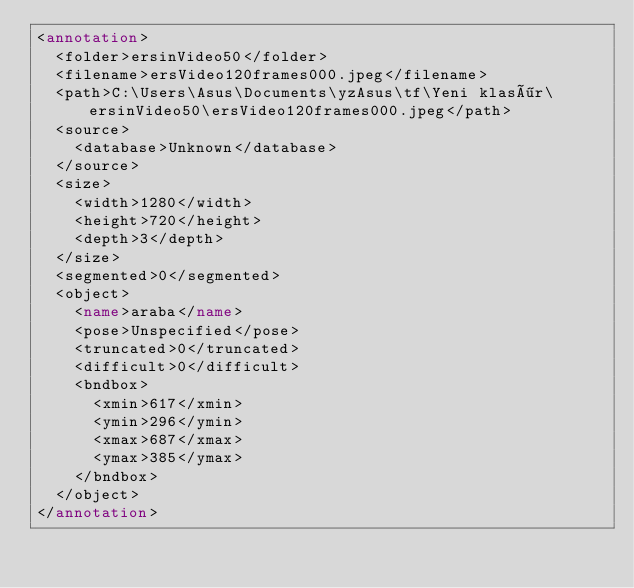Convert code to text. <code><loc_0><loc_0><loc_500><loc_500><_XML_><annotation>
	<folder>ersinVideo50</folder>
	<filename>ersVideo120frames000.jpeg</filename>
	<path>C:\Users\Asus\Documents\yzAsus\tf\Yeni klasör\ersinVideo50\ersVideo120frames000.jpeg</path>
	<source>
		<database>Unknown</database>
	</source>
	<size>
		<width>1280</width>
		<height>720</height>
		<depth>3</depth>
	</size>
	<segmented>0</segmented>
	<object>
		<name>araba</name>
		<pose>Unspecified</pose>
		<truncated>0</truncated>
		<difficult>0</difficult>
		<bndbox>
			<xmin>617</xmin>
			<ymin>296</ymin>
			<xmax>687</xmax>
			<ymax>385</ymax>
		</bndbox>
	</object>
</annotation>
</code> 